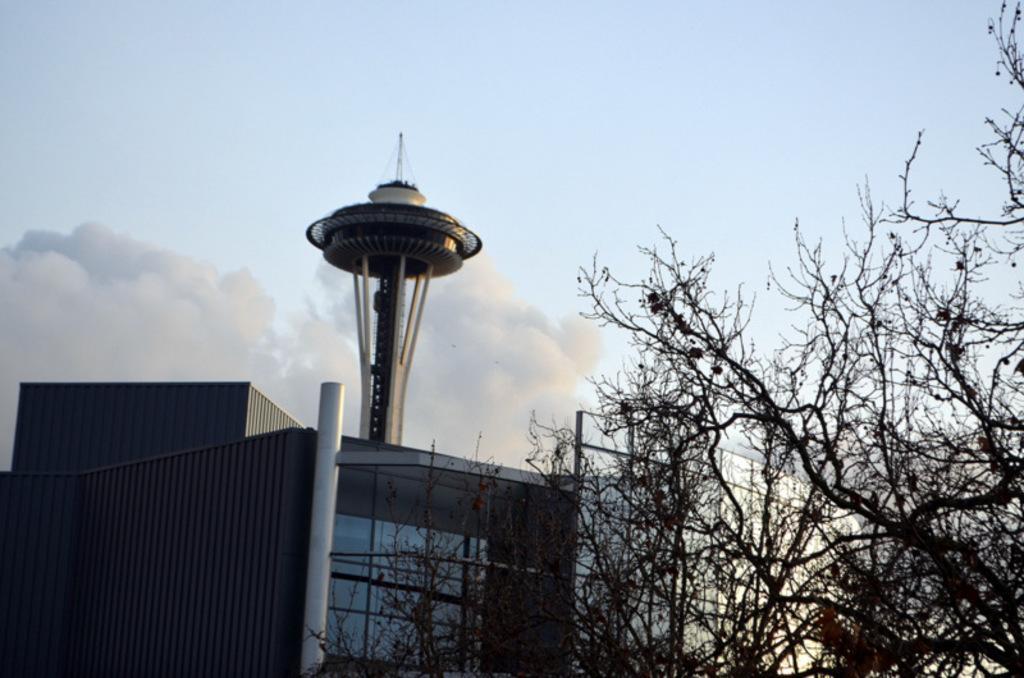Describe this image in one or two sentences. In this picture I can observe trees in the middle of the picture. In the background I can observe a building, tower and some clouds in the sky. 